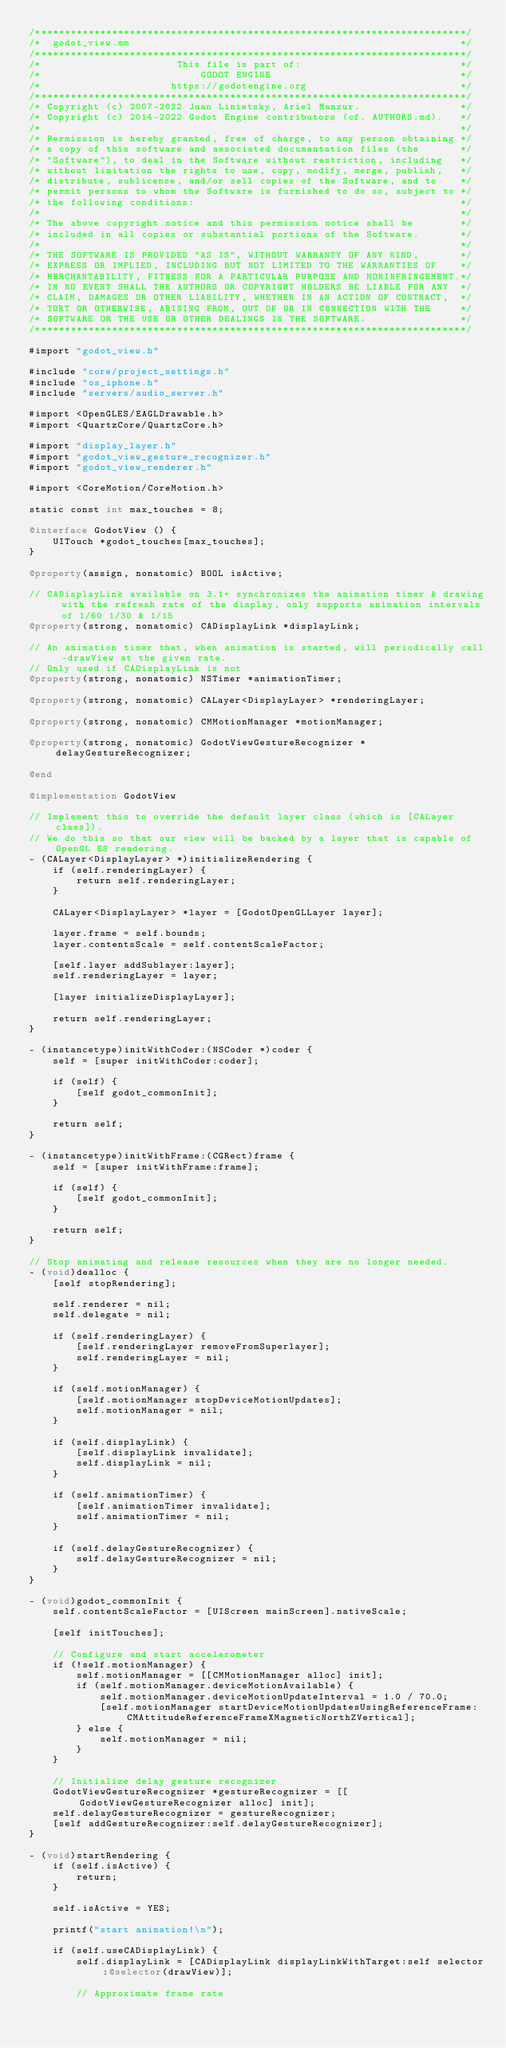<code> <loc_0><loc_0><loc_500><loc_500><_ObjectiveC_>/*************************************************************************/
/*  godot_view.mm                                                        */
/*************************************************************************/
/*                       This file is part of:                           */
/*                           GODOT ENGINE                                */
/*                      https://godotengine.org                          */
/*************************************************************************/
/* Copyright (c) 2007-2022 Juan Linietsky, Ariel Manzur.                 */
/* Copyright (c) 2014-2022 Godot Engine contributors (cf. AUTHORS.md).   */
/*                                                                       */
/* Permission is hereby granted, free of charge, to any person obtaining */
/* a copy of this software and associated documentation files (the       */
/* "Software"), to deal in the Software without restriction, including   */
/* without limitation the rights to use, copy, modify, merge, publish,   */
/* distribute, sublicense, and/or sell copies of the Software, and to    */
/* permit persons to whom the Software is furnished to do so, subject to */
/* the following conditions:                                             */
/*                                                                       */
/* The above copyright notice and this permission notice shall be        */
/* included in all copies or substantial portions of the Software.       */
/*                                                                       */
/* THE SOFTWARE IS PROVIDED "AS IS", WITHOUT WARRANTY OF ANY KIND,       */
/* EXPRESS OR IMPLIED, INCLUDING BUT NOT LIMITED TO THE WARRANTIES OF    */
/* MERCHANTABILITY, FITNESS FOR A PARTICULAR PURPOSE AND NONINFRINGEMENT.*/
/* IN NO EVENT SHALL THE AUTHORS OR COPYRIGHT HOLDERS BE LIABLE FOR ANY  */
/* CLAIM, DAMAGES OR OTHER LIABILITY, WHETHER IN AN ACTION OF CONTRACT,  */
/* TORT OR OTHERWISE, ARISING FROM, OUT OF OR IN CONNECTION WITH THE     */
/* SOFTWARE OR THE USE OR OTHER DEALINGS IN THE SOFTWARE.                */
/*************************************************************************/

#import "godot_view.h"

#include "core/project_settings.h"
#include "os_iphone.h"
#include "servers/audio_server.h"

#import <OpenGLES/EAGLDrawable.h>
#import <QuartzCore/QuartzCore.h>

#import "display_layer.h"
#import "godot_view_gesture_recognizer.h"
#import "godot_view_renderer.h"

#import <CoreMotion/CoreMotion.h>

static const int max_touches = 8;

@interface GodotView () {
	UITouch *godot_touches[max_touches];
}

@property(assign, nonatomic) BOOL isActive;

// CADisplayLink available on 3.1+ synchronizes the animation timer & drawing with the refresh rate of the display, only supports animation intervals of 1/60 1/30 & 1/15
@property(strong, nonatomic) CADisplayLink *displayLink;

// An animation timer that, when animation is started, will periodically call -drawView at the given rate.
// Only used if CADisplayLink is not
@property(strong, nonatomic) NSTimer *animationTimer;

@property(strong, nonatomic) CALayer<DisplayLayer> *renderingLayer;

@property(strong, nonatomic) CMMotionManager *motionManager;

@property(strong, nonatomic) GodotViewGestureRecognizer *delayGestureRecognizer;

@end

@implementation GodotView

// Implement this to override the default layer class (which is [CALayer class]).
// We do this so that our view will be backed by a layer that is capable of OpenGL ES rendering.
- (CALayer<DisplayLayer> *)initializeRendering {
	if (self.renderingLayer) {
		return self.renderingLayer;
	}

	CALayer<DisplayLayer> *layer = [GodotOpenGLLayer layer];

	layer.frame = self.bounds;
	layer.contentsScale = self.contentScaleFactor;

	[self.layer addSublayer:layer];
	self.renderingLayer = layer;

	[layer initializeDisplayLayer];

	return self.renderingLayer;
}

- (instancetype)initWithCoder:(NSCoder *)coder {
	self = [super initWithCoder:coder];

	if (self) {
		[self godot_commonInit];
	}

	return self;
}

- (instancetype)initWithFrame:(CGRect)frame {
	self = [super initWithFrame:frame];

	if (self) {
		[self godot_commonInit];
	}

	return self;
}

// Stop animating and release resources when they are no longer needed.
- (void)dealloc {
	[self stopRendering];

	self.renderer = nil;
	self.delegate = nil;

	if (self.renderingLayer) {
		[self.renderingLayer removeFromSuperlayer];
		self.renderingLayer = nil;
	}

	if (self.motionManager) {
		[self.motionManager stopDeviceMotionUpdates];
		self.motionManager = nil;
	}

	if (self.displayLink) {
		[self.displayLink invalidate];
		self.displayLink = nil;
	}

	if (self.animationTimer) {
		[self.animationTimer invalidate];
		self.animationTimer = nil;
	}

	if (self.delayGestureRecognizer) {
		self.delayGestureRecognizer = nil;
	}
}

- (void)godot_commonInit {
	self.contentScaleFactor = [UIScreen mainScreen].nativeScale;

	[self initTouches];

	// Configure and start accelerometer
	if (!self.motionManager) {
		self.motionManager = [[CMMotionManager alloc] init];
		if (self.motionManager.deviceMotionAvailable) {
			self.motionManager.deviceMotionUpdateInterval = 1.0 / 70.0;
			[self.motionManager startDeviceMotionUpdatesUsingReferenceFrame:CMAttitudeReferenceFrameXMagneticNorthZVertical];
		} else {
			self.motionManager = nil;
		}
	}

	// Initialize delay gesture recognizer
	GodotViewGestureRecognizer *gestureRecognizer = [[GodotViewGestureRecognizer alloc] init];
	self.delayGestureRecognizer = gestureRecognizer;
	[self addGestureRecognizer:self.delayGestureRecognizer];
}

- (void)startRendering {
	if (self.isActive) {
		return;
	}

	self.isActive = YES;

	printf("start animation!\n");

	if (self.useCADisplayLink) {
		self.displayLink = [CADisplayLink displayLinkWithTarget:self selector:@selector(drawView)];

		// Approximate frame rate</code> 